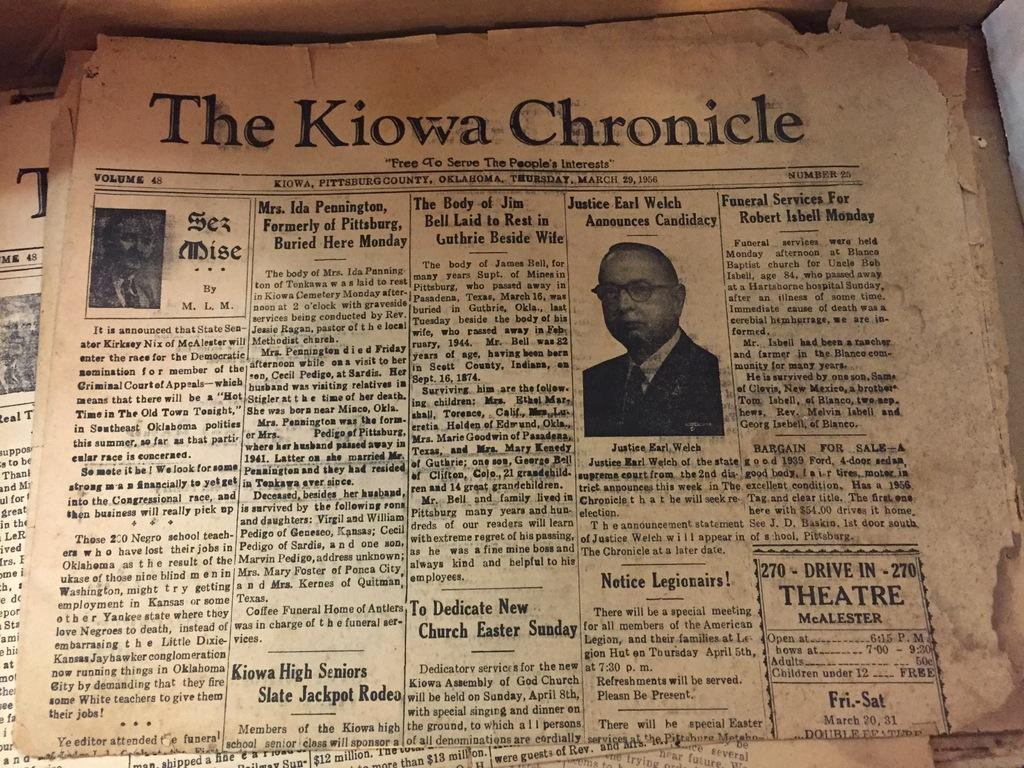What is present on the papers in the image? The papers contain photographs of people and text. What type of content can be found on the papers? The papers contain photographs of people and text. How many pears can be seen in the image? There are no pears present in the image. Can you describe the elbow of the person in the image? There is no person or elbow present in the image; it only contains papers with photographs and text. 